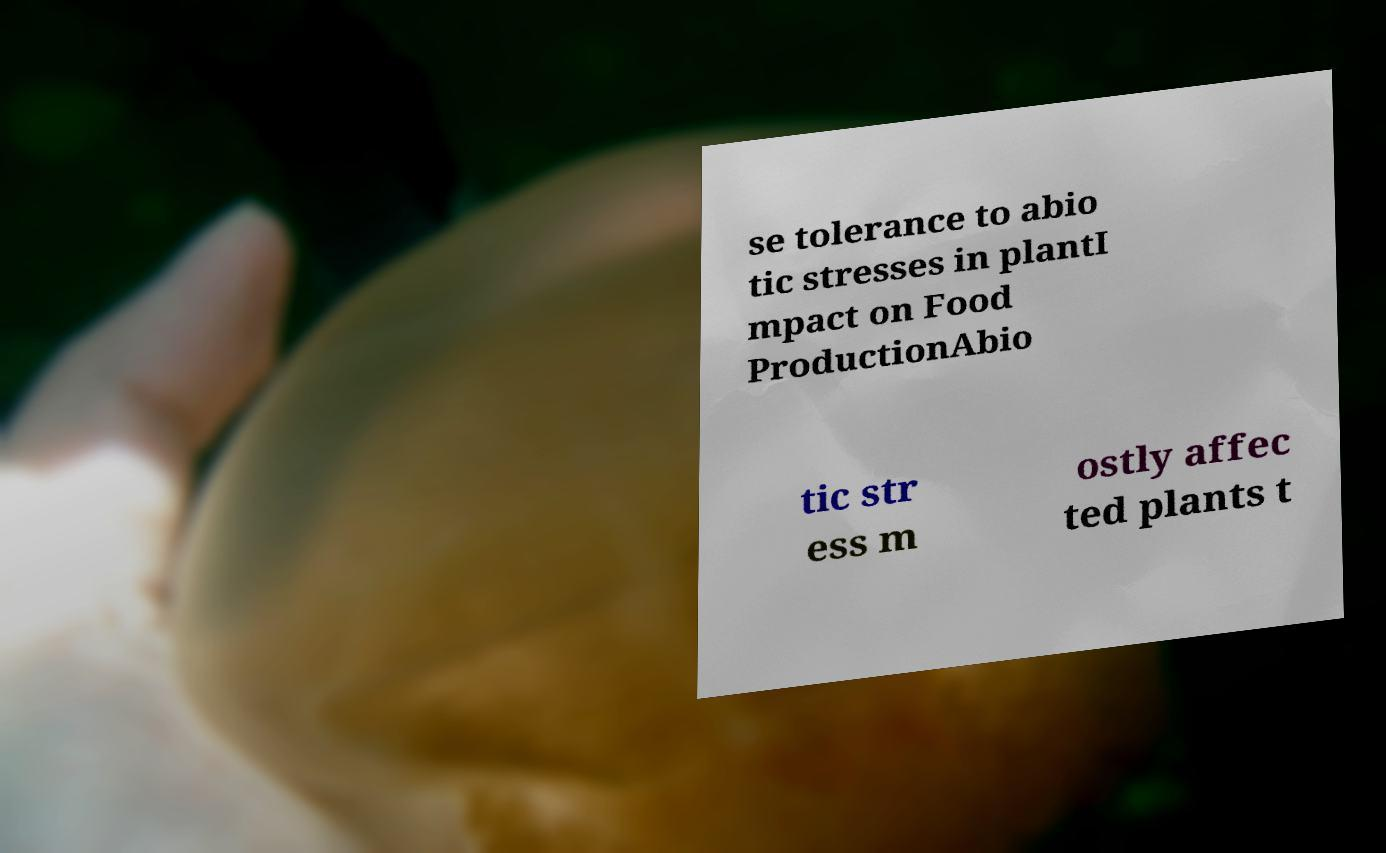Could you extract and type out the text from this image? se tolerance to abio tic stresses in plantI mpact on Food ProductionAbio tic str ess m ostly affec ted plants t 